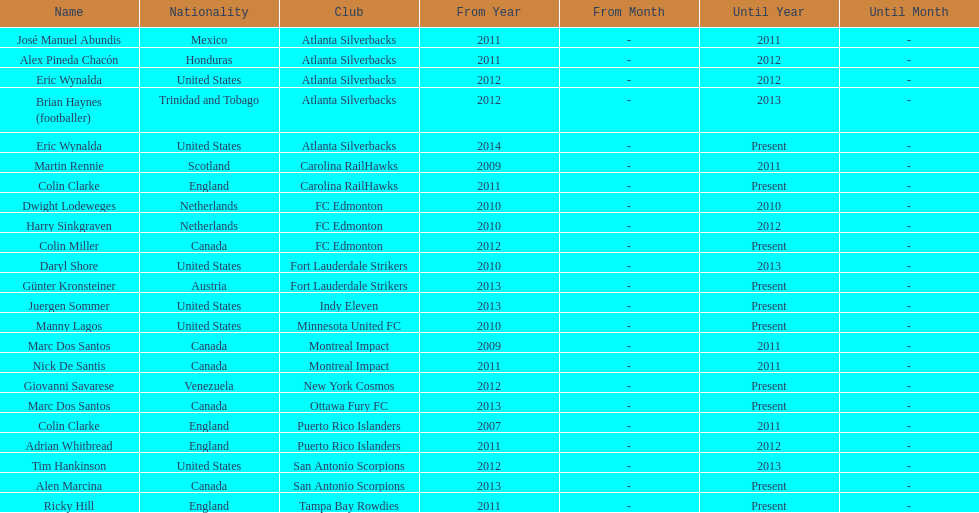What name is listed at the top? José Manuel Abundis. 